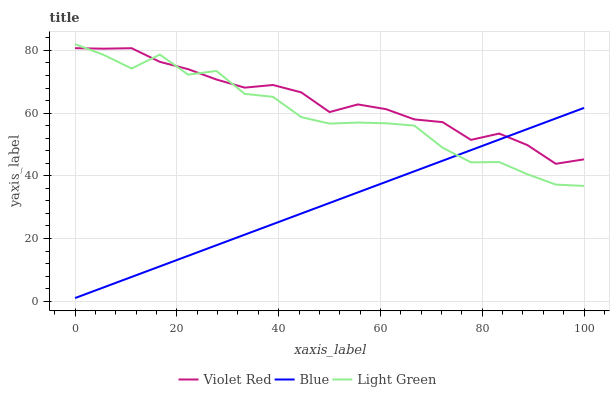Does Blue have the minimum area under the curve?
Answer yes or no. Yes. Does Violet Red have the maximum area under the curve?
Answer yes or no. Yes. Does Light Green have the minimum area under the curve?
Answer yes or no. No. Does Light Green have the maximum area under the curve?
Answer yes or no. No. Is Blue the smoothest?
Answer yes or no. Yes. Is Light Green the roughest?
Answer yes or no. Yes. Is Violet Red the smoothest?
Answer yes or no. No. Is Violet Red the roughest?
Answer yes or no. No. Does Blue have the lowest value?
Answer yes or no. Yes. Does Light Green have the lowest value?
Answer yes or no. No. Does Light Green have the highest value?
Answer yes or no. Yes. Does Violet Red have the highest value?
Answer yes or no. No. Does Light Green intersect Violet Red?
Answer yes or no. Yes. Is Light Green less than Violet Red?
Answer yes or no. No. Is Light Green greater than Violet Red?
Answer yes or no. No. 